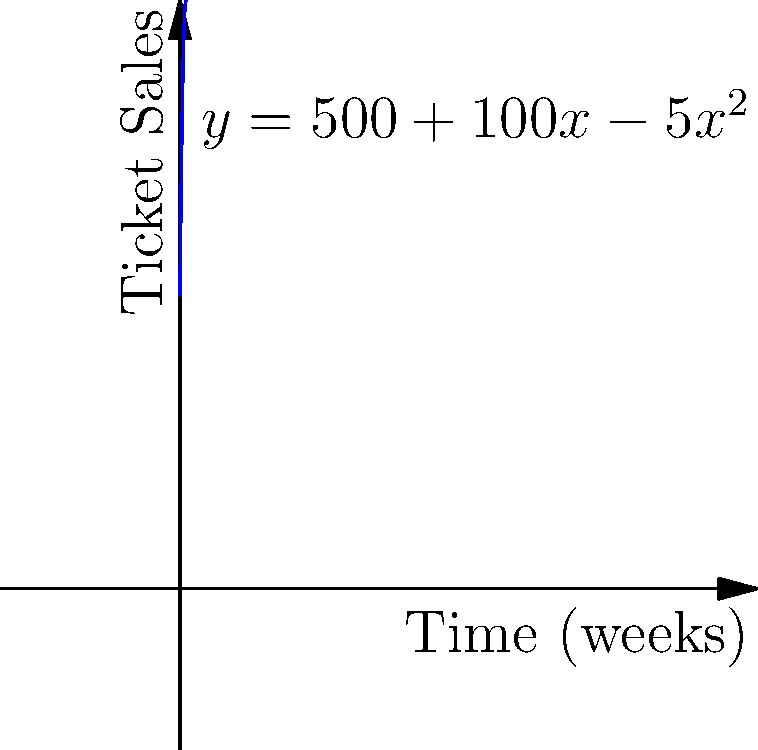You're organizing a Queen tribute concert, and ticket sales follow the function $y = 500 + 100x - 5x^2$, where $y$ represents the number of tickets sold and $x$ is the number of weeks since sales began. At what point in time is the rate of ticket sales equal to zero, and what does this indicate about the concert's popularity? To solve this problem, we need to follow these steps:

1) The rate of ticket sales is represented by the derivative of the given function.

2) Let's find the derivative:
   $y = 500 + 100x - 5x^2$
   $\frac{dy}{dx} = 100 - 10x$

3) We want to find when the rate of sales is zero:
   $100 - 10x = 0$

4) Solve this equation:
   $-10x = -100$
   $x = 10$

5) This means that after 10 weeks, the rate of ticket sales becomes zero.

6) To understand what this indicates about the concert's popularity, we need to consider what happens before and after this point:
   - Before 10 weeks: $\frac{dy}{dx} > 0$, sales are increasing
   - At 10 weeks: $\frac{dy}{dx} = 0$, sales reach their peak
   - After 10 weeks: $\frac{dy}{dx} < 0$, sales start to decrease

7) Therefore, this point indicates the peak of the concert's popularity. After 10 weeks, ticket sales will start to decline.
Answer: 10 weeks; peak popularity 